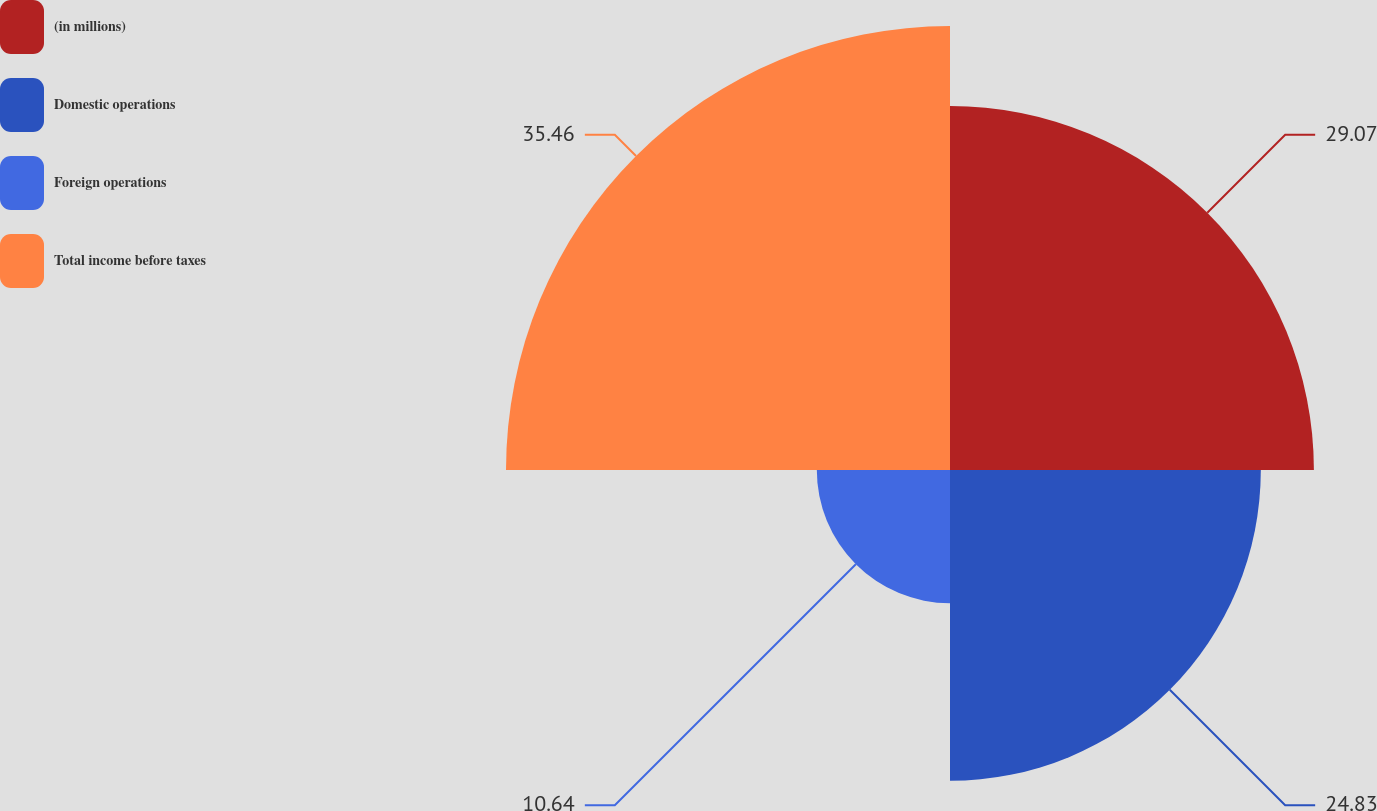Convert chart to OTSL. <chart><loc_0><loc_0><loc_500><loc_500><pie_chart><fcel>(in millions)<fcel>Domestic operations<fcel>Foreign operations<fcel>Total income before taxes<nl><fcel>29.07%<fcel>24.83%<fcel>10.64%<fcel>35.47%<nl></chart> 